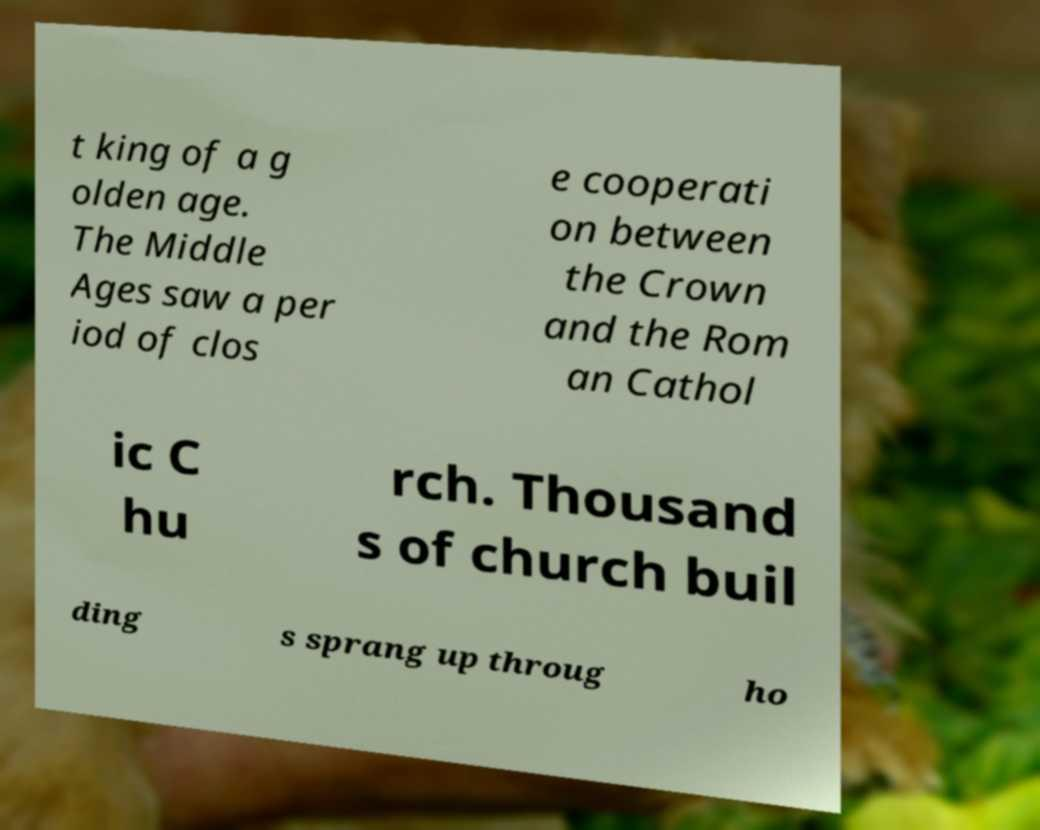There's text embedded in this image that I need extracted. Can you transcribe it verbatim? t king of a g olden age. The Middle Ages saw a per iod of clos e cooperati on between the Crown and the Rom an Cathol ic C hu rch. Thousand s of church buil ding s sprang up throug ho 